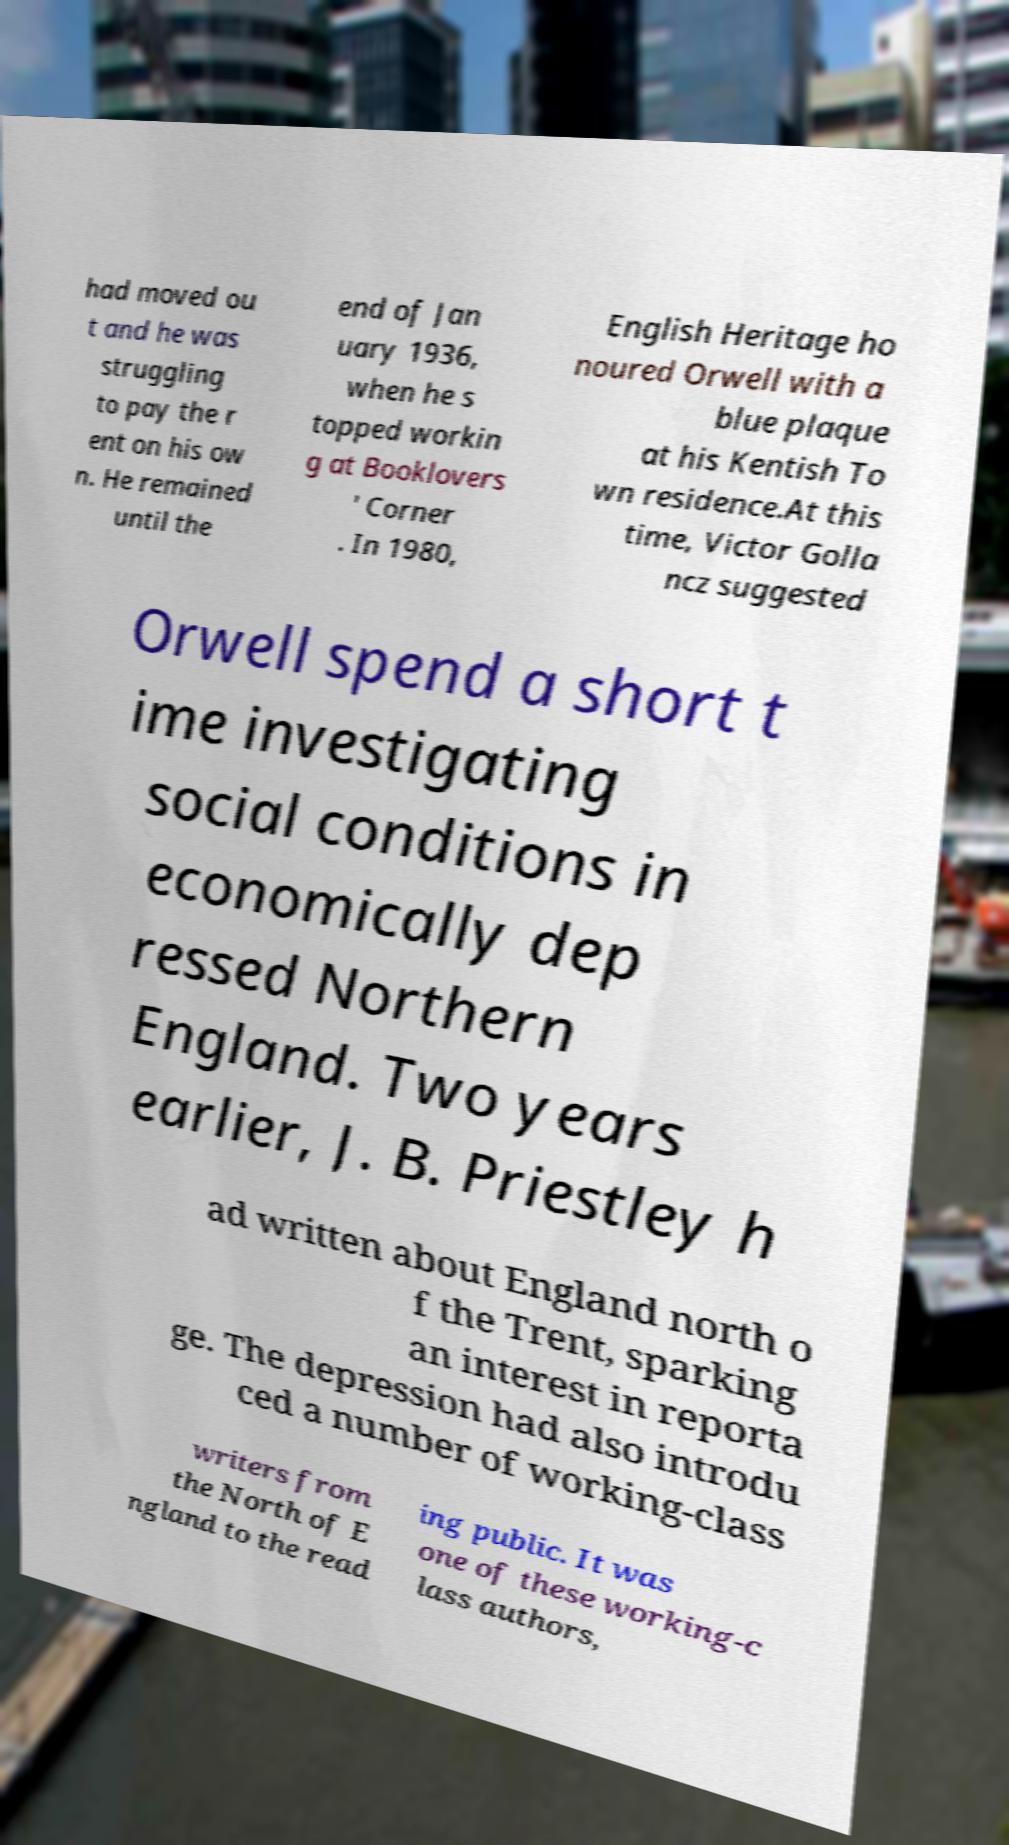Can you accurately transcribe the text from the provided image for me? had moved ou t and he was struggling to pay the r ent on his ow n. He remained until the end of Jan uary 1936, when he s topped workin g at Booklovers ' Corner . In 1980, English Heritage ho noured Orwell with a blue plaque at his Kentish To wn residence.At this time, Victor Golla ncz suggested Orwell spend a short t ime investigating social conditions in economically dep ressed Northern England. Two years earlier, J. B. Priestley h ad written about England north o f the Trent, sparking an interest in reporta ge. The depression had also introdu ced a number of working-class writers from the North of E ngland to the read ing public. It was one of these working-c lass authors, 